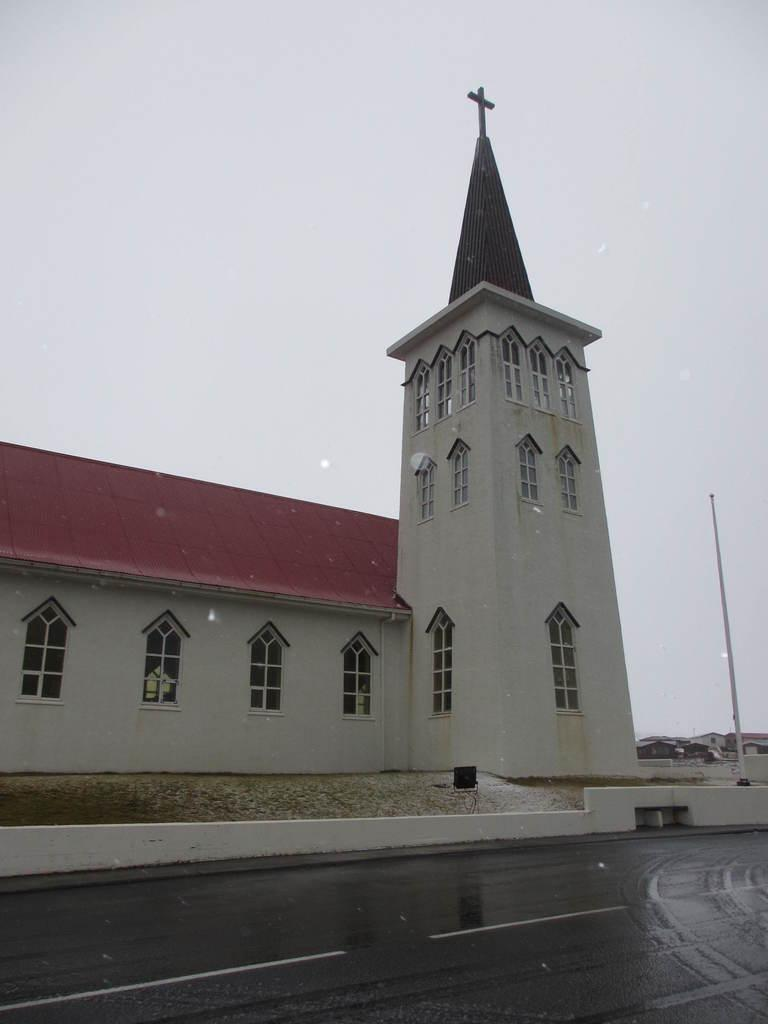What type of building is the main subject of the image? There is a church in the image. Where is the church situated in relation to the road? The church is located on the side of the road. What other structures can be seen in the background of the image? There are homes visible behind the church. What part of the natural environment is visible in the image? The sky is visible above the church and homes. What type of seed is being planted by the sisters in the image? There are no sisters or seeds present in the image; it features a church located on the side of the road with homes and the sky visible in the background. 